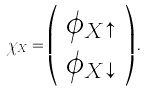<formula> <loc_0><loc_0><loc_500><loc_500>\chi _ { X } = \left ( \begin{array} { l } \phi _ { X \uparrow } \\ \phi _ { X \downarrow } \end{array} \right ) .</formula> 